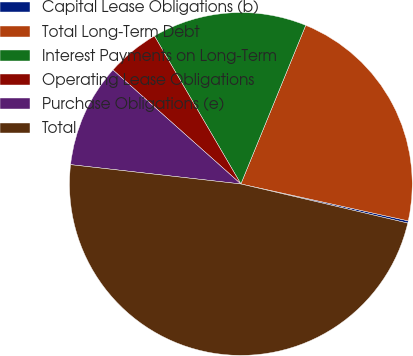<chart> <loc_0><loc_0><loc_500><loc_500><pie_chart><fcel>Capital Lease Obligations (b)<fcel>Total Long-Term Debt<fcel>Interest Payments on Long-Term<fcel>Operating Lease Obligations<fcel>Purchase Obligations (e)<fcel>Total<nl><fcel>0.21%<fcel>22.28%<fcel>14.59%<fcel>5.0%<fcel>9.79%<fcel>48.14%<nl></chart> 